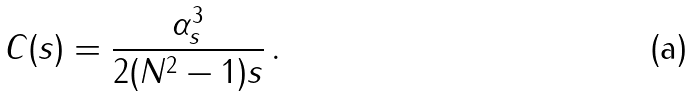Convert formula to latex. <formula><loc_0><loc_0><loc_500><loc_500>C ( s ) = \frac { \alpha _ { s } ^ { 3 } } { 2 ( N ^ { 2 } - 1 ) s } \, .</formula> 